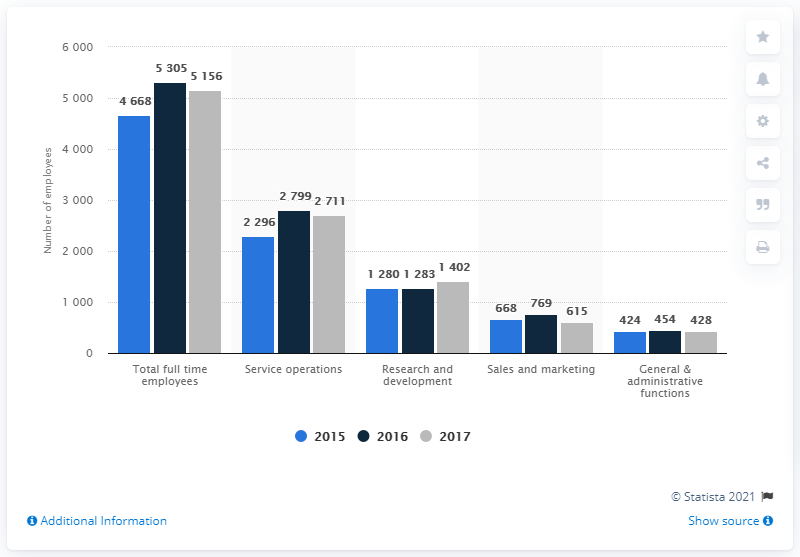Highlight a few significant elements in this photo. In 2015, the total number of full-time employees was the highest among all the years. As of the current date, the total number of employees in sales and marketing is 2052. 